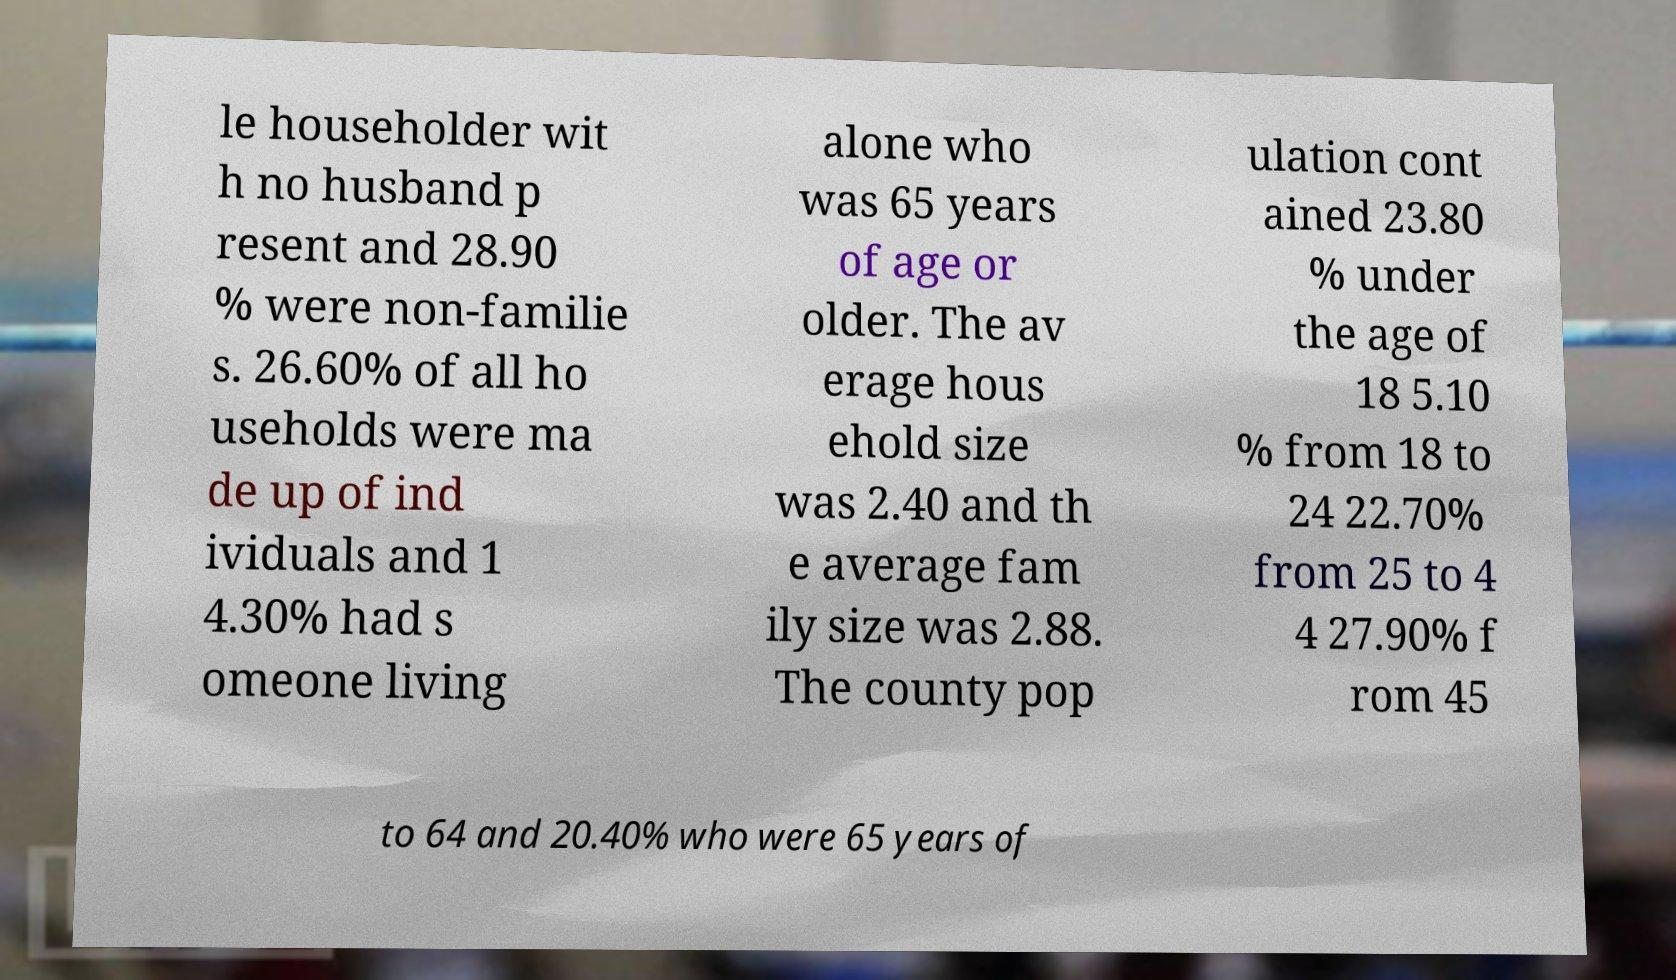Please identify and transcribe the text found in this image. le householder wit h no husband p resent and 28.90 % were non-familie s. 26.60% of all ho useholds were ma de up of ind ividuals and 1 4.30% had s omeone living alone who was 65 years of age or older. The av erage hous ehold size was 2.40 and th e average fam ily size was 2.88. The county pop ulation cont ained 23.80 % under the age of 18 5.10 % from 18 to 24 22.70% from 25 to 4 4 27.90% f rom 45 to 64 and 20.40% who were 65 years of 